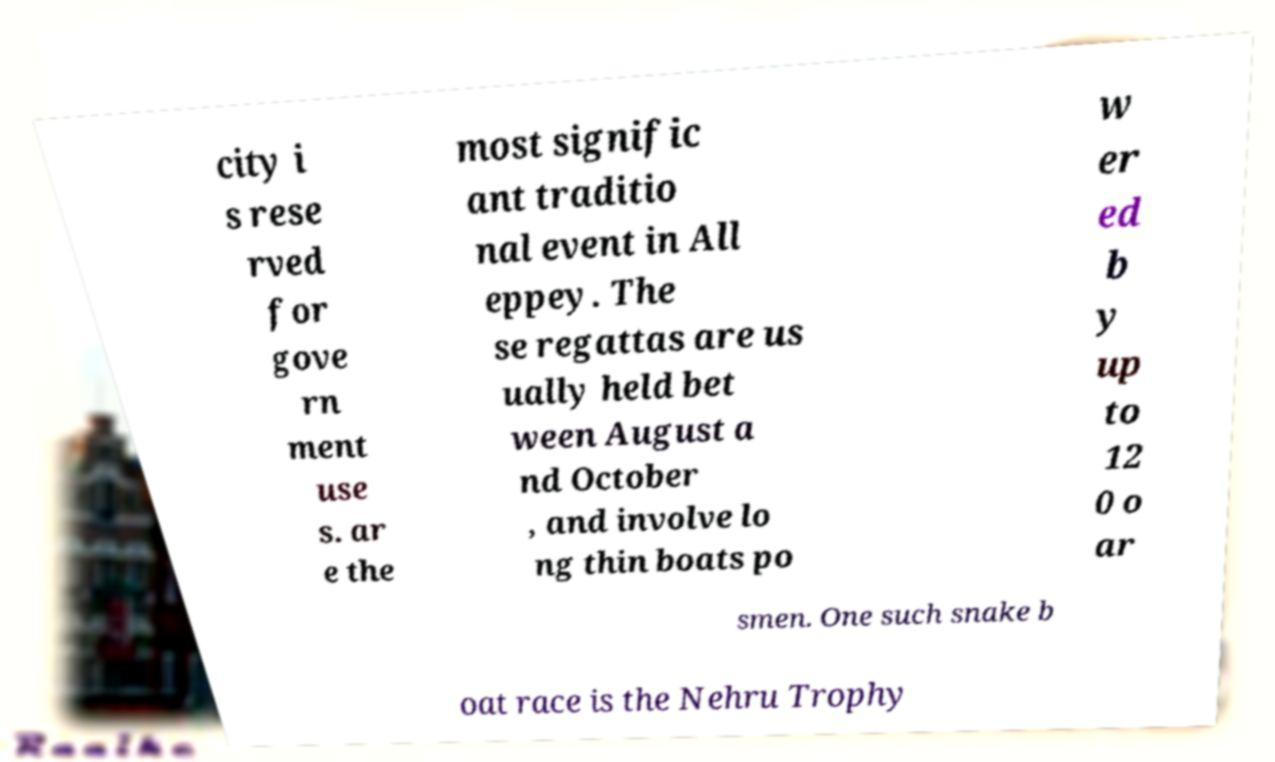Can you read and provide the text displayed in the image?This photo seems to have some interesting text. Can you extract and type it out for me? city i s rese rved for gove rn ment use s. ar e the most signific ant traditio nal event in All eppey. The se regattas are us ually held bet ween August a nd October , and involve lo ng thin boats po w er ed b y up to 12 0 o ar smen. One such snake b oat race is the Nehru Trophy 